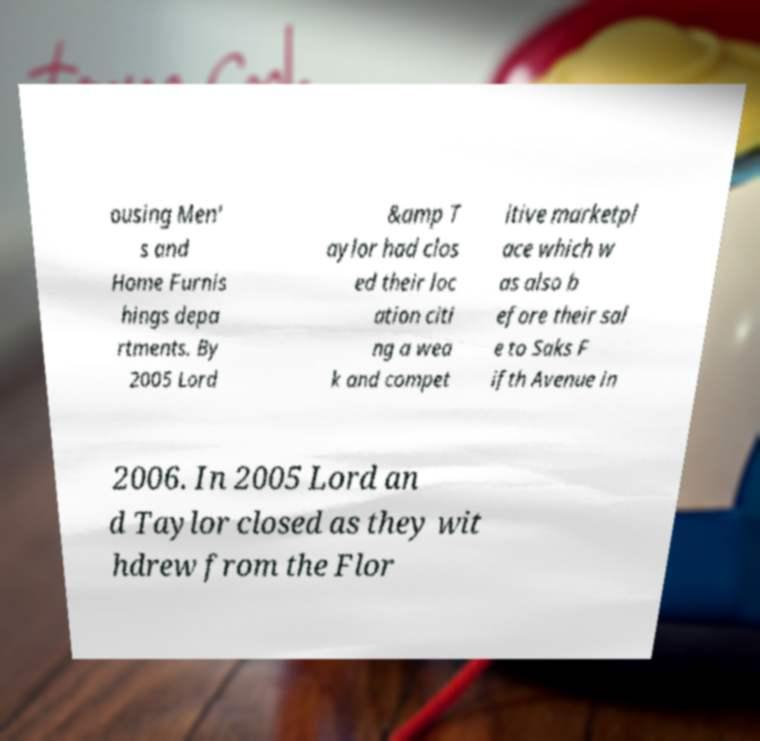Could you extract and type out the text from this image? ousing Men' s and Home Furnis hings depa rtments. By 2005 Lord &amp T aylor had clos ed their loc ation citi ng a wea k and compet itive marketpl ace which w as also b efore their sal e to Saks F ifth Avenue in 2006. In 2005 Lord an d Taylor closed as they wit hdrew from the Flor 